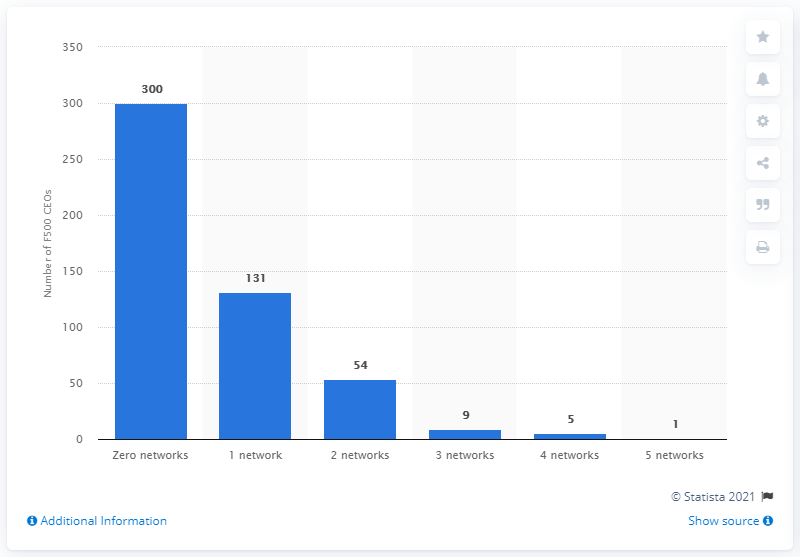Point out several critical features in this image. In the most recent survey period, 300 Fortune 500 CEOs did not have any active social media accounts. Out of the 131 CEOs surveyed, only 1% had only one social media account. 